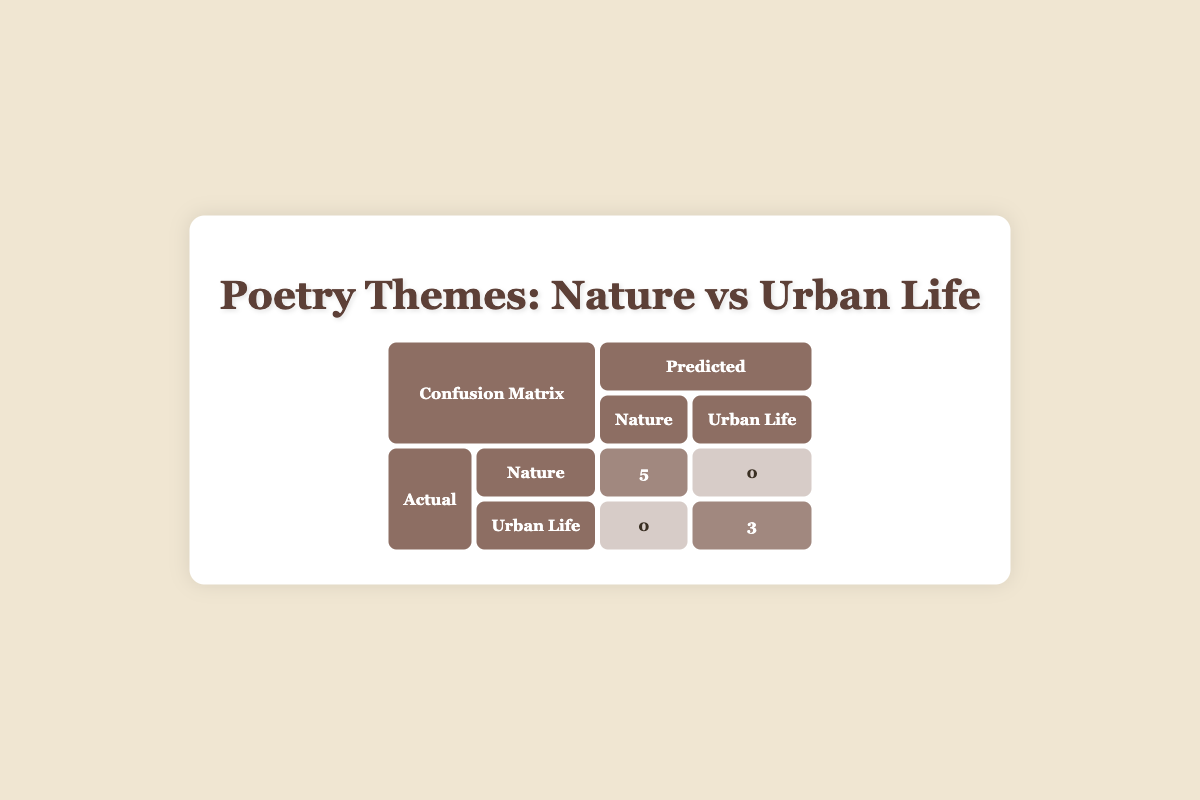What is the predicted number of poetry collections for the theme "Nature"? According to the table, the predicted number for the theme "Nature" is 5.
Answer: 5 What is the actual number of poetry collections for the theme "Urban Life"? The table indicates that the actual number for the theme "Urban Life" is 3.
Answer: 3 Is there any poetry collection that was misclassified? The table shows that the predicted counts match the actual counts for both themes, indicating that there are no misclassifications.
Answer: No What is the total number of poetry collections in the confusion matrix? The total number can be calculated by adding the predicted values: 5 (Nature) + 3 (Urban Life) = 8. Therefore, the total number is 8.
Answer: 8 What is the difference between the predicted number of "Nature" and "Urban Life"? The predicted count for "Nature" is 5, while for "Urban Life" it is 3. The difference is 5 - 3 = 2.
Answer: 2 What percentage of the actual collections are classified as "Nature"? To find the percentage, divide the actual number of "Nature" collections (5) by the total actual collections (5 + 3 = 8), which gives 5/8 = 0.625. Multiplying by 100 gives 62.5%.
Answer: 62.5% Are the predicted and actual counts the same for "Natural" poetry collections? Yes, the table shows that both predicted and actual counts for "Natural" poetry collections are 5.
Answer: Yes What are the themes represented in the poetry collections? The themes presented in the poetry collections are "Nature" and "Urban Life," as indicated in the title of the confusion matrix.
Answer: Nature and Urban Life 